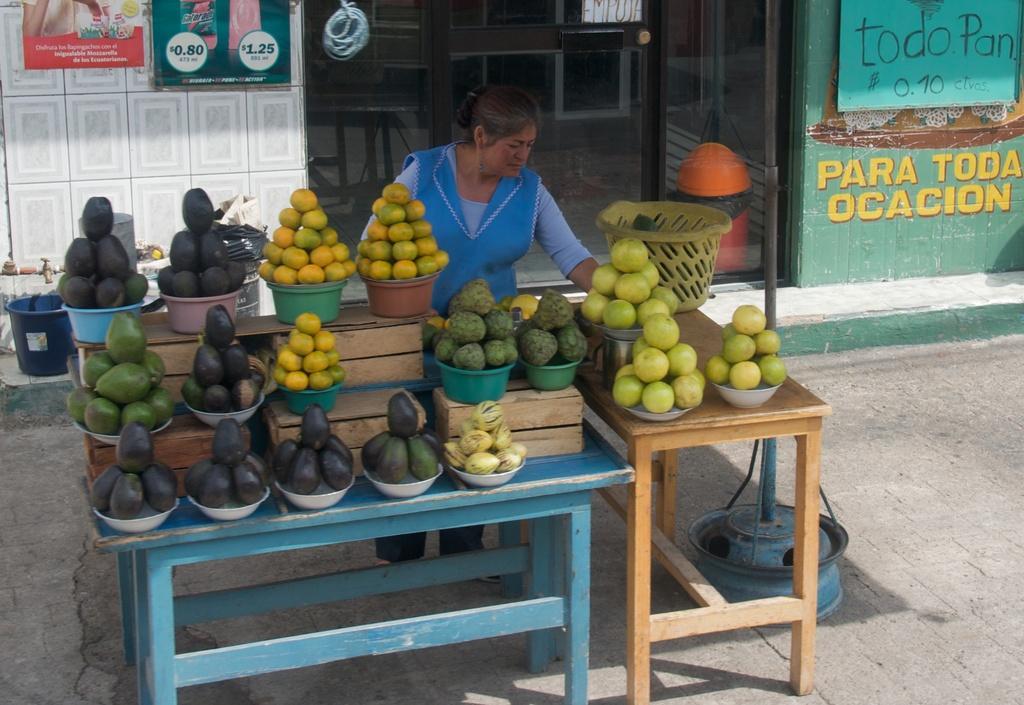In one or two sentences, can you explain what this image depicts? In this image, we can see a person. We can see some tables. We can also see some food items in bowls. We can see the ground with some objects. We can also see a pole. In the background, we can see the wall with some posters. We can also see the glass door. We can also see a bucket on the left. 